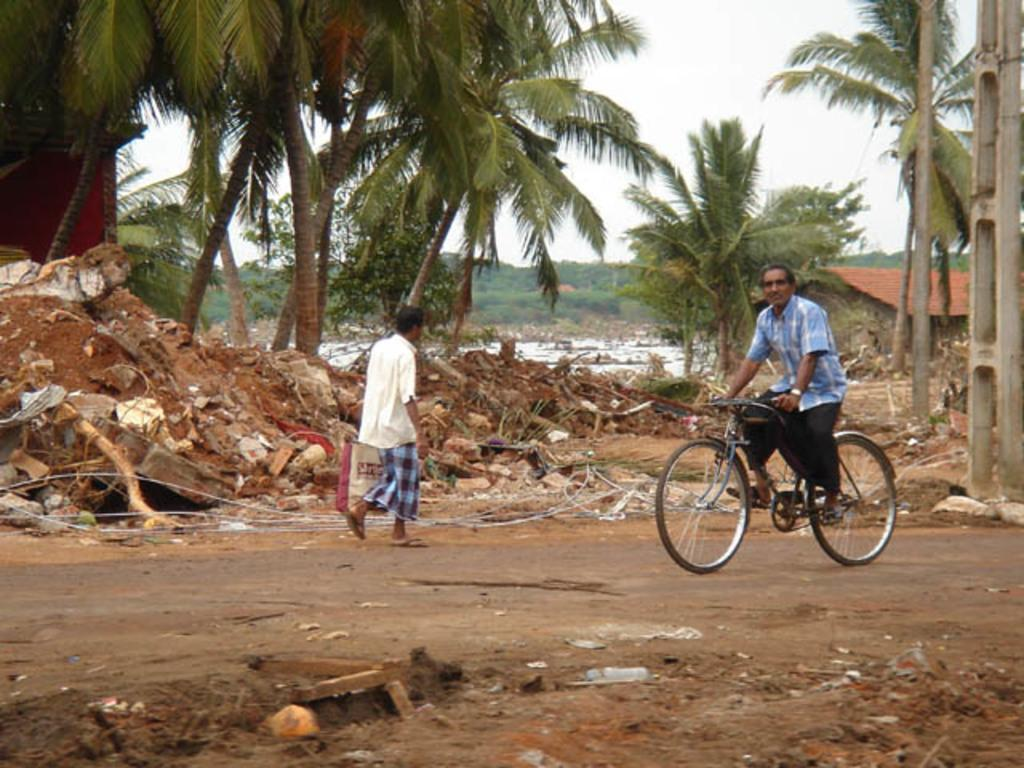What is the man in the image doing? There is a man sitting on a bicycle in the image. What is the other man in the image doing? There is another man standing on the road in the image. What can be seen in the background of the image? There are trees visible in the background of the image. What type of zinc is being used to make the bicycle in the image? There is no mention of zinc or any materials used to make the bicycle in the image. 